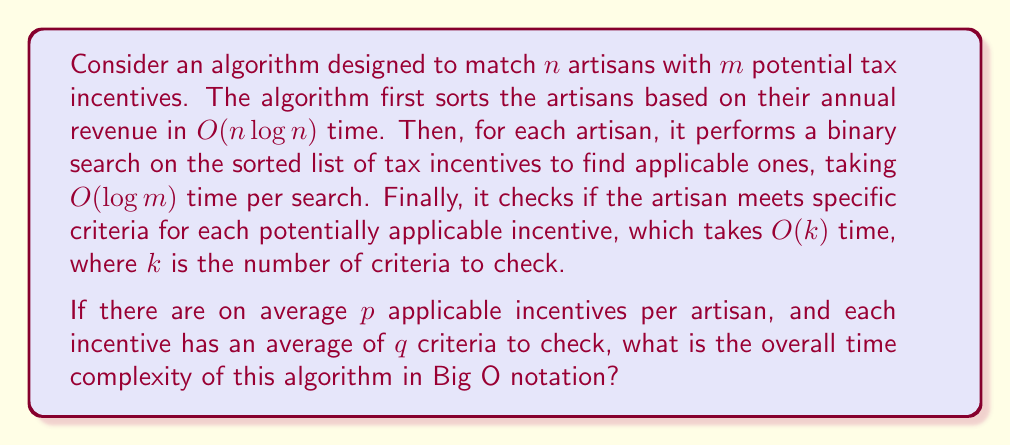Can you answer this question? Let's break down the algorithm and analyze each step:

1. Sorting artisans: $O(n \log n)$

2. For each artisan (n times):
   a. Binary search on incentives: $O(\log m)$
   b. Checking criteria for applicable incentives: $O(p \cdot q)$
      (p applicable incentives, each with q criteria on average)

The total time for step 2 is: $n \cdot (O(\log m) + O(p \cdot q))$

Combining steps 1 and 2:

$$O(n \log n) + n \cdot (O(\log m) + O(p \cdot q))$$

Simplifying:

$$O(n \log n) + O(n \log m) + O(n p q)$$

To determine the dominant term, we need to compare $\log n$, $\log m$, and $p q$.

Since $p$ and $q$ are average values and likely small constants, $p q$ is also a constant. Therefore, $O(n p q)$ simplifies to $O(n)$.

The overall time complexity is the maximum of these terms:

$$O(\max(n \log n, n \log m, n))$$

Since $\log n$ and $\log m$ are always greater than 1 (for $n, m > 2$), the linear term $O(n)$ is dominated by the other two terms and can be omitted.

Thus, the final time complexity is:

$$O(n \max(\log n, \log m))$$
Answer: $O(n \max(\log n, \log m))$ 